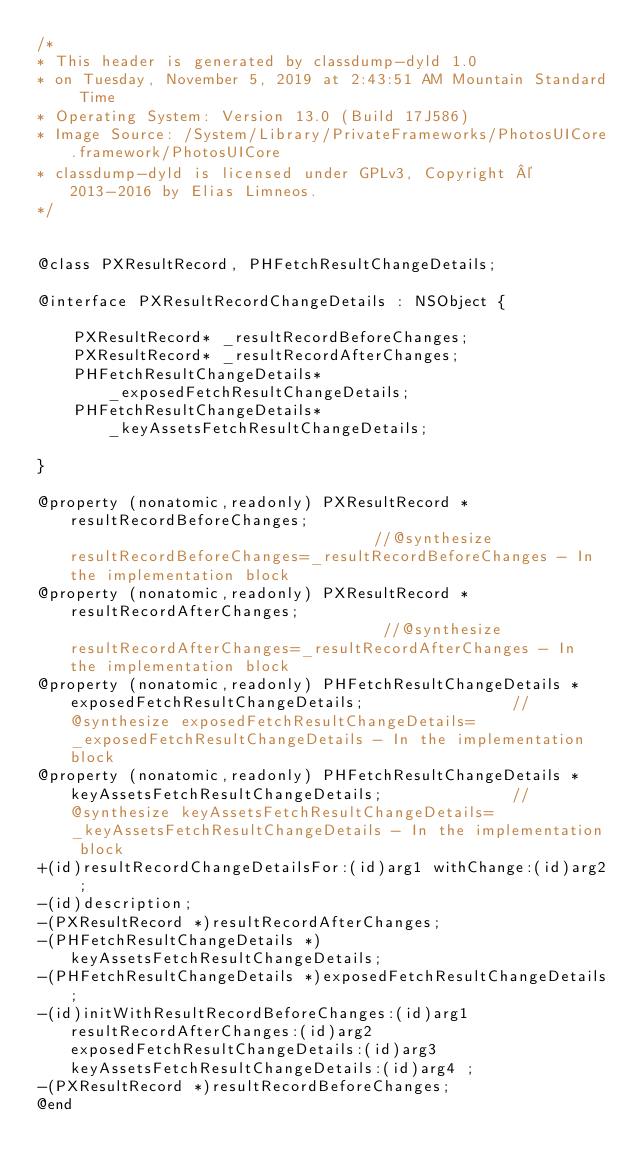<code> <loc_0><loc_0><loc_500><loc_500><_C_>/*
* This header is generated by classdump-dyld 1.0
* on Tuesday, November 5, 2019 at 2:43:51 AM Mountain Standard Time
* Operating System: Version 13.0 (Build 17J586)
* Image Source: /System/Library/PrivateFrameworks/PhotosUICore.framework/PhotosUICore
* classdump-dyld is licensed under GPLv3, Copyright © 2013-2016 by Elias Limneos.
*/


@class PXResultRecord, PHFetchResultChangeDetails;

@interface PXResultRecordChangeDetails : NSObject {

	PXResultRecord* _resultRecordBeforeChanges;
	PXResultRecord* _resultRecordAfterChanges;
	PHFetchResultChangeDetails* _exposedFetchResultChangeDetails;
	PHFetchResultChangeDetails* _keyAssetsFetchResultChangeDetails;

}

@property (nonatomic,readonly) PXResultRecord * resultRecordBeforeChanges;                                  //@synthesize resultRecordBeforeChanges=_resultRecordBeforeChanges - In the implementation block
@property (nonatomic,readonly) PXResultRecord * resultRecordAfterChanges;                                   //@synthesize resultRecordAfterChanges=_resultRecordAfterChanges - In the implementation block
@property (nonatomic,readonly) PHFetchResultChangeDetails * exposedFetchResultChangeDetails;                //@synthesize exposedFetchResultChangeDetails=_exposedFetchResultChangeDetails - In the implementation block
@property (nonatomic,readonly) PHFetchResultChangeDetails * keyAssetsFetchResultChangeDetails;              //@synthesize keyAssetsFetchResultChangeDetails=_keyAssetsFetchResultChangeDetails - In the implementation block
+(id)resultRecordChangeDetailsFor:(id)arg1 withChange:(id)arg2 ;
-(id)description;
-(PXResultRecord *)resultRecordAfterChanges;
-(PHFetchResultChangeDetails *)keyAssetsFetchResultChangeDetails;
-(PHFetchResultChangeDetails *)exposedFetchResultChangeDetails;
-(id)initWithResultRecordBeforeChanges:(id)arg1 resultRecordAfterChanges:(id)arg2 exposedFetchResultChangeDetails:(id)arg3 keyAssetsFetchResultChangeDetails:(id)arg4 ;
-(PXResultRecord *)resultRecordBeforeChanges;
@end

</code> 